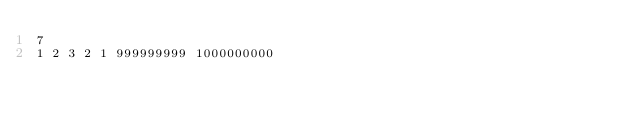Convert code to text. <code><loc_0><loc_0><loc_500><loc_500><_C#_>7
1 2 3 2 1 999999999 1000000000</code> 